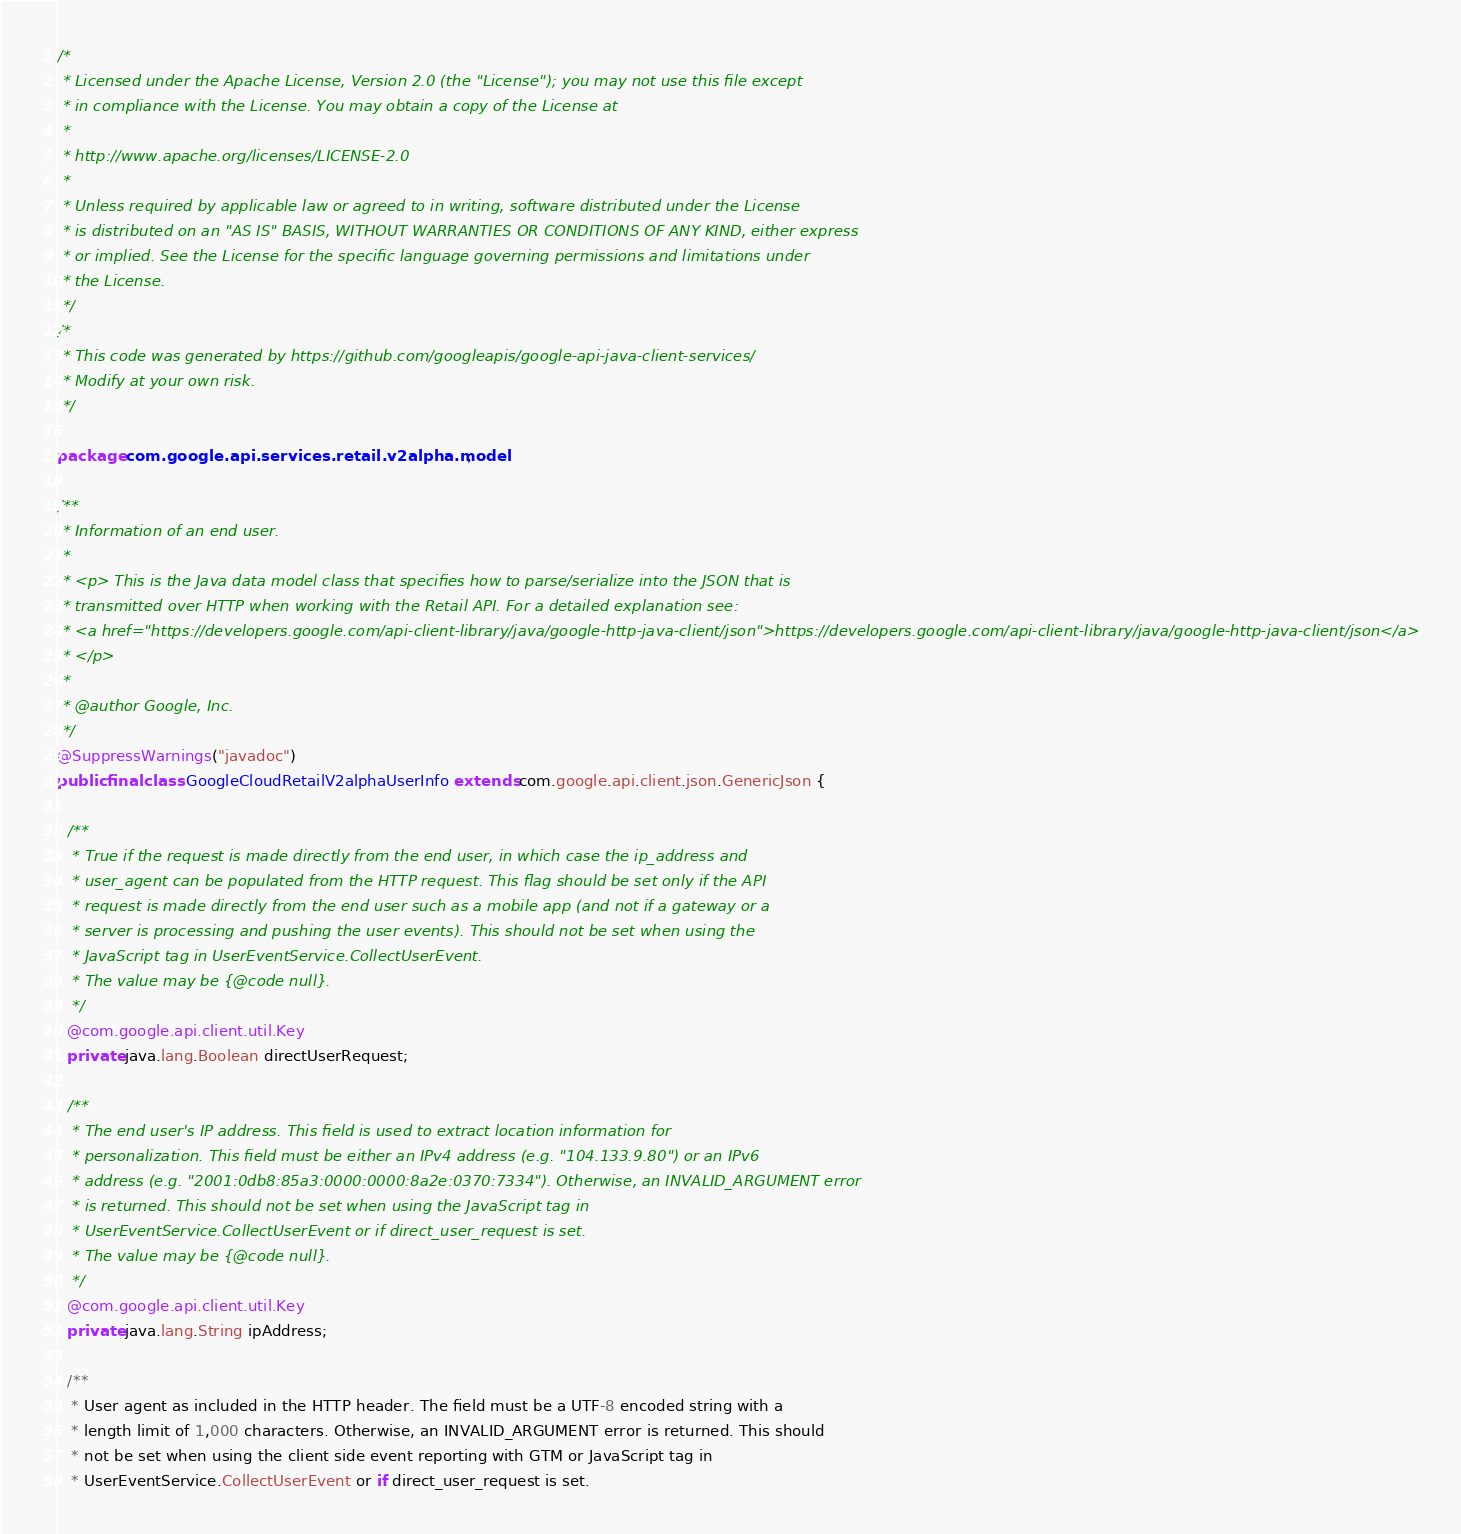<code> <loc_0><loc_0><loc_500><loc_500><_Java_>/*
 * Licensed under the Apache License, Version 2.0 (the "License"); you may not use this file except
 * in compliance with the License. You may obtain a copy of the License at
 *
 * http://www.apache.org/licenses/LICENSE-2.0
 *
 * Unless required by applicable law or agreed to in writing, software distributed under the License
 * is distributed on an "AS IS" BASIS, WITHOUT WARRANTIES OR CONDITIONS OF ANY KIND, either express
 * or implied. See the License for the specific language governing permissions and limitations under
 * the License.
 */
/*
 * This code was generated by https://github.com/googleapis/google-api-java-client-services/
 * Modify at your own risk.
 */

package com.google.api.services.retail.v2alpha.model;

/**
 * Information of an end user.
 *
 * <p> This is the Java data model class that specifies how to parse/serialize into the JSON that is
 * transmitted over HTTP when working with the Retail API. For a detailed explanation see:
 * <a href="https://developers.google.com/api-client-library/java/google-http-java-client/json">https://developers.google.com/api-client-library/java/google-http-java-client/json</a>
 * </p>
 *
 * @author Google, Inc.
 */
@SuppressWarnings("javadoc")
public final class GoogleCloudRetailV2alphaUserInfo extends com.google.api.client.json.GenericJson {

  /**
   * True if the request is made directly from the end user, in which case the ip_address and
   * user_agent can be populated from the HTTP request. This flag should be set only if the API
   * request is made directly from the end user such as a mobile app (and not if a gateway or a
   * server is processing and pushing the user events). This should not be set when using the
   * JavaScript tag in UserEventService.CollectUserEvent.
   * The value may be {@code null}.
   */
  @com.google.api.client.util.Key
  private java.lang.Boolean directUserRequest;

  /**
   * The end user's IP address. This field is used to extract location information for
   * personalization. This field must be either an IPv4 address (e.g. "104.133.9.80") or an IPv6
   * address (e.g. "2001:0db8:85a3:0000:0000:8a2e:0370:7334"). Otherwise, an INVALID_ARGUMENT error
   * is returned. This should not be set when using the JavaScript tag in
   * UserEventService.CollectUserEvent or if direct_user_request is set.
   * The value may be {@code null}.
   */
  @com.google.api.client.util.Key
  private java.lang.String ipAddress;

  /**
   * User agent as included in the HTTP header. The field must be a UTF-8 encoded string with a
   * length limit of 1,000 characters. Otherwise, an INVALID_ARGUMENT error is returned. This should
   * not be set when using the client side event reporting with GTM or JavaScript tag in
   * UserEventService.CollectUserEvent or if direct_user_request is set.</code> 